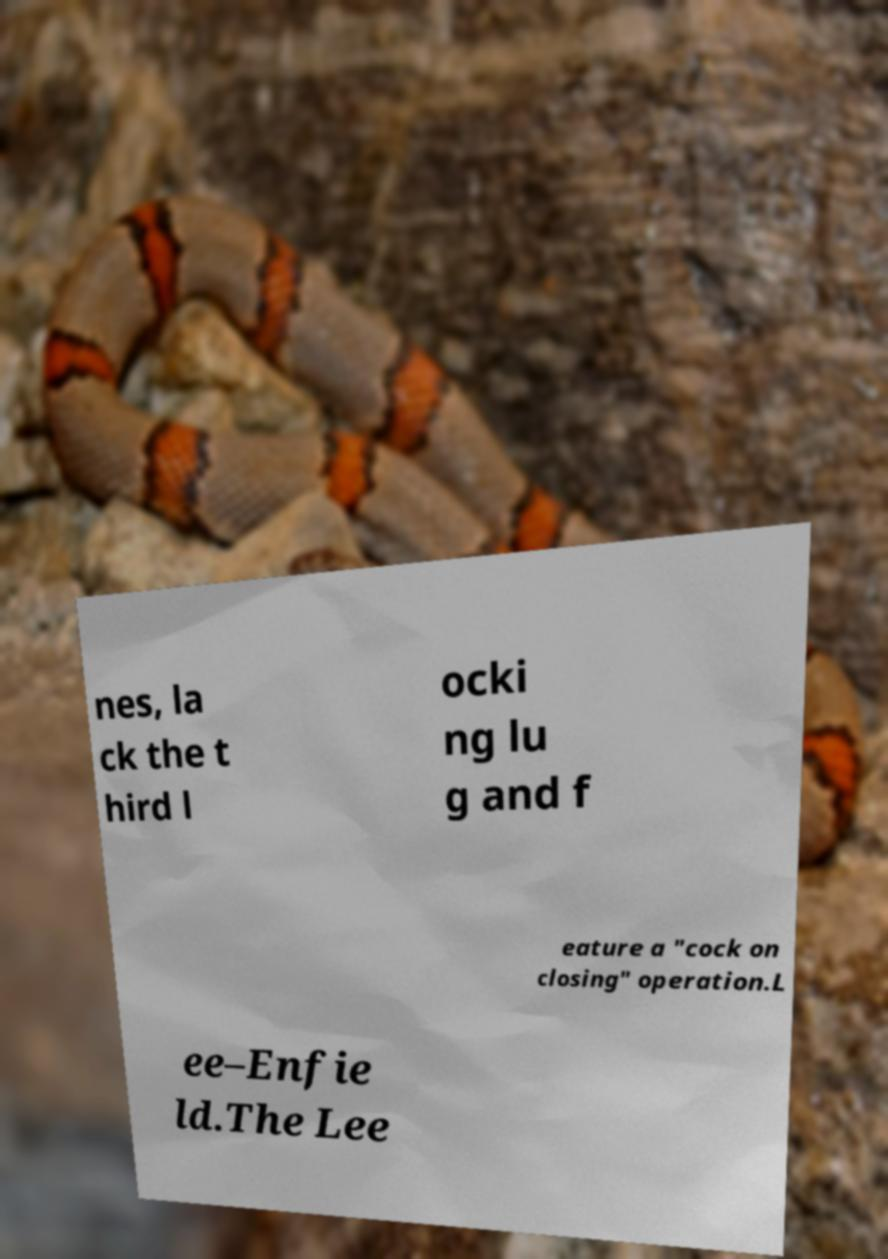I need the written content from this picture converted into text. Can you do that? nes, la ck the t hird l ocki ng lu g and f eature a "cock on closing" operation.L ee–Enfie ld.The Lee 